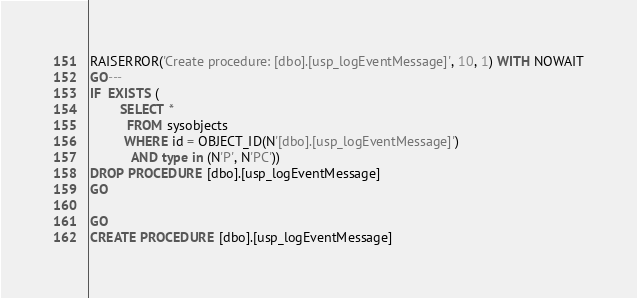Convert code to text. <code><loc_0><loc_0><loc_500><loc_500><_SQL_>RAISERROR('Create procedure: [dbo].[usp_logEventMessage]', 10, 1) WITH NOWAIT
GO---
IF  EXISTS (
	    SELECT * 
	      FROM sysobjects 
	     WHERE id = OBJECT_ID(N'[dbo].[usp_logEventMessage]') 
	       AND type in (N'P', N'PC'))
DROP PROCEDURE [dbo].[usp_logEventMessage]
GO

GO
CREATE PROCEDURE [dbo].[usp_logEventMessage]</code> 